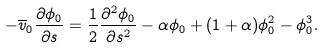<formula> <loc_0><loc_0><loc_500><loc_500>- \overline { v } _ { 0 } \frac { \partial \phi _ { 0 } } { \partial s } = \frac { 1 } { 2 } \frac { \partial ^ { 2 } \phi _ { 0 } } { \partial s ^ { 2 } } - \alpha \phi _ { 0 } + ( 1 + \alpha ) \phi _ { 0 } ^ { 2 } - \phi _ { 0 } ^ { 3 } .</formula> 